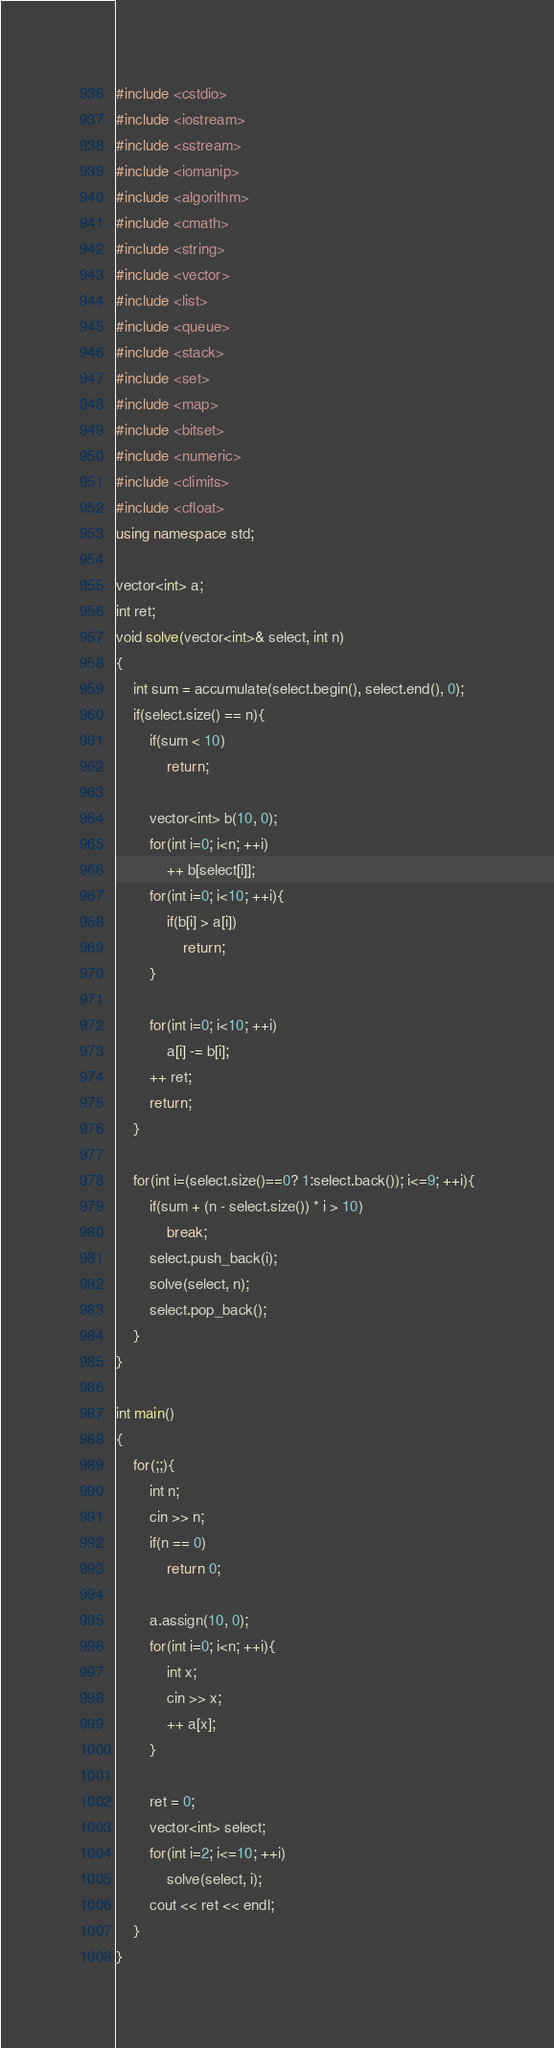<code> <loc_0><loc_0><loc_500><loc_500><_C++_>#include <cstdio>
#include <iostream>
#include <sstream>
#include <iomanip>
#include <algorithm>
#include <cmath>
#include <string>
#include <vector>
#include <list>
#include <queue>
#include <stack>
#include <set>
#include <map>
#include <bitset>
#include <numeric>
#include <climits>
#include <cfloat>
using namespace std;

vector<int> a;
int ret;
void solve(vector<int>& select, int n)
{
    int sum = accumulate(select.begin(), select.end(), 0);
    if(select.size() == n){
        if(sum < 10)
            return;

        vector<int> b(10, 0);
        for(int i=0; i<n; ++i)
            ++ b[select[i]];
        for(int i=0; i<10; ++i){
            if(b[i] > a[i])
                return;
        }

        for(int i=0; i<10; ++i)
            a[i] -= b[i];
        ++ ret;
        return;
    }

    for(int i=(select.size()==0? 1:select.back()); i<=9; ++i){
        if(sum + (n - select.size()) * i > 10)
            break;
        select.push_back(i);
        solve(select, n);
        select.pop_back();
    }
}

int main()
{
    for(;;){
        int n;
        cin >> n;
        if(n == 0)
            return 0;

        a.assign(10, 0);
        for(int i=0; i<n; ++i){
            int x;
            cin >> x;
            ++ a[x];
        }

        ret = 0;
        vector<int> select;
        for(int i=2; i<=10; ++i)
            solve(select, i);
        cout << ret << endl;
    }
}</code> 